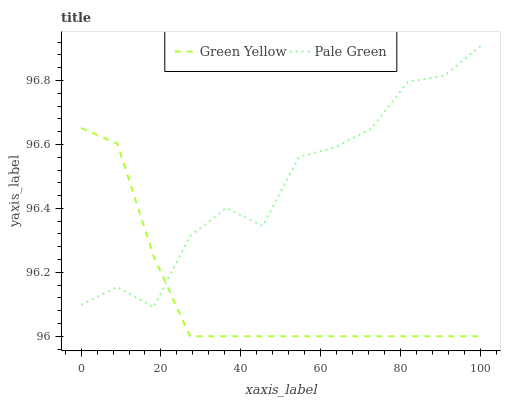Does Green Yellow have the minimum area under the curve?
Answer yes or no. Yes. Does Pale Green have the maximum area under the curve?
Answer yes or no. Yes. Does Green Yellow have the maximum area under the curve?
Answer yes or no. No. Is Green Yellow the smoothest?
Answer yes or no. Yes. Is Pale Green the roughest?
Answer yes or no. Yes. Is Green Yellow the roughest?
Answer yes or no. No. Does Green Yellow have the lowest value?
Answer yes or no. Yes. Does Pale Green have the highest value?
Answer yes or no. Yes. Does Green Yellow have the highest value?
Answer yes or no. No. Does Pale Green intersect Green Yellow?
Answer yes or no. Yes. Is Pale Green less than Green Yellow?
Answer yes or no. No. Is Pale Green greater than Green Yellow?
Answer yes or no. No. 